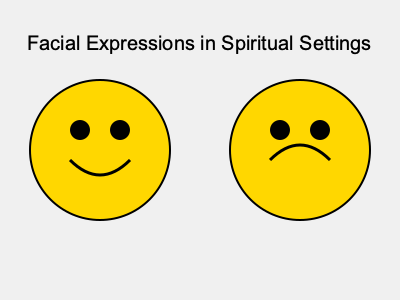In the context of spiritual gatherings, which emotion is more likely to be associated with the facial expression on the right, and how might this relate to your personal journey of faith? 1. Analyze the facial features:
   - Left face: Upward curved mouth (smile)
   - Right face: Downward curved mouth (frown)

2. Interpret emotions:
   - Left face: Happiness, joy, or contentment
   - Right face: Sadness, contemplation, or introspection

3. Consider spiritual context:
   - Happiness may represent fulfillment or connection
   - Sadness may indicate struggle, doubt, or deep reflection

4. Relate to personal faith journey:
   - The right face (sadness/contemplation) often aligns with questioning or grappling with faith
   - This expression may resonate more with a lapsed believer's experience

5. Deeper meaning:
   - Sadness in spiritual settings can represent:
     a) Wrestling with difficult questions
     b) Confronting past beliefs
     c) Seeking authentic spiritual experiences

6. Conclusion:
   The right face likely represents contemplation or sadness, which may be more relatable to someone questioning their faith.
Answer: Contemplation or sadness 